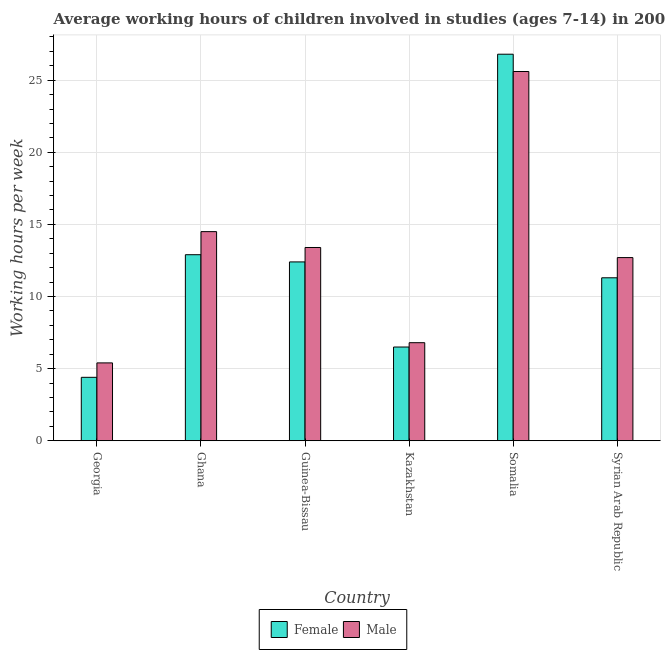How many groups of bars are there?
Ensure brevity in your answer.  6. Are the number of bars on each tick of the X-axis equal?
Your answer should be compact. Yes. How many bars are there on the 6th tick from the left?
Provide a short and direct response. 2. How many bars are there on the 2nd tick from the right?
Ensure brevity in your answer.  2. What is the label of the 6th group of bars from the left?
Your response must be concise. Syrian Arab Republic. What is the average working hour of female children in Syrian Arab Republic?
Offer a terse response. 11.3. Across all countries, what is the maximum average working hour of female children?
Make the answer very short. 26.8. Across all countries, what is the minimum average working hour of male children?
Provide a short and direct response. 5.4. In which country was the average working hour of male children maximum?
Ensure brevity in your answer.  Somalia. In which country was the average working hour of male children minimum?
Provide a short and direct response. Georgia. What is the total average working hour of male children in the graph?
Provide a succinct answer. 78.4. What is the difference between the average working hour of male children in Ghana and that in Guinea-Bissau?
Your response must be concise. 1.1. What is the difference between the average working hour of female children in Syrian Arab Republic and the average working hour of male children in Guinea-Bissau?
Make the answer very short. -2.1. What is the average average working hour of male children per country?
Your response must be concise. 13.07. What is the difference between the average working hour of male children and average working hour of female children in Ghana?
Your answer should be very brief. 1.6. What is the ratio of the average working hour of female children in Guinea-Bissau to that in Somalia?
Offer a very short reply. 0.46. Is the difference between the average working hour of female children in Somalia and Syrian Arab Republic greater than the difference between the average working hour of male children in Somalia and Syrian Arab Republic?
Ensure brevity in your answer.  Yes. What is the difference between the highest and the lowest average working hour of female children?
Your answer should be very brief. 22.4. In how many countries, is the average working hour of female children greater than the average average working hour of female children taken over all countries?
Provide a succinct answer. 3. What does the 1st bar from the right in Somalia represents?
Keep it short and to the point. Male. How many bars are there?
Give a very brief answer. 12. Are all the bars in the graph horizontal?
Offer a terse response. No. How many countries are there in the graph?
Make the answer very short. 6. Does the graph contain grids?
Your response must be concise. Yes. Where does the legend appear in the graph?
Make the answer very short. Bottom center. What is the title of the graph?
Provide a succinct answer. Average working hours of children involved in studies (ages 7-14) in 2006. Does "Transport services" appear as one of the legend labels in the graph?
Ensure brevity in your answer.  No. What is the label or title of the X-axis?
Your response must be concise. Country. What is the label or title of the Y-axis?
Your answer should be compact. Working hours per week. What is the Working hours per week in Female in Georgia?
Provide a short and direct response. 4.4. What is the Working hours per week in Male in Georgia?
Keep it short and to the point. 5.4. What is the Working hours per week in Male in Guinea-Bissau?
Make the answer very short. 13.4. What is the Working hours per week of Female in Somalia?
Provide a succinct answer. 26.8. What is the Working hours per week in Male in Somalia?
Offer a very short reply. 25.6. What is the Working hours per week in Female in Syrian Arab Republic?
Provide a succinct answer. 11.3. What is the Working hours per week in Male in Syrian Arab Republic?
Provide a succinct answer. 12.7. Across all countries, what is the maximum Working hours per week in Female?
Offer a very short reply. 26.8. Across all countries, what is the maximum Working hours per week in Male?
Ensure brevity in your answer.  25.6. Across all countries, what is the minimum Working hours per week of Female?
Provide a short and direct response. 4.4. Across all countries, what is the minimum Working hours per week in Male?
Your answer should be very brief. 5.4. What is the total Working hours per week of Female in the graph?
Your answer should be very brief. 74.3. What is the total Working hours per week in Male in the graph?
Provide a succinct answer. 78.4. What is the difference between the Working hours per week in Female in Georgia and that in Ghana?
Provide a short and direct response. -8.5. What is the difference between the Working hours per week of Male in Georgia and that in Ghana?
Keep it short and to the point. -9.1. What is the difference between the Working hours per week in Female in Georgia and that in Somalia?
Provide a short and direct response. -22.4. What is the difference between the Working hours per week of Male in Georgia and that in Somalia?
Your response must be concise. -20.2. What is the difference between the Working hours per week in Female in Georgia and that in Syrian Arab Republic?
Offer a very short reply. -6.9. What is the difference between the Working hours per week in Male in Georgia and that in Syrian Arab Republic?
Your answer should be very brief. -7.3. What is the difference between the Working hours per week of Female in Ghana and that in Somalia?
Your answer should be very brief. -13.9. What is the difference between the Working hours per week in Male in Ghana and that in Somalia?
Your response must be concise. -11.1. What is the difference between the Working hours per week of Female in Guinea-Bissau and that in Somalia?
Offer a very short reply. -14.4. What is the difference between the Working hours per week in Male in Guinea-Bissau and that in Syrian Arab Republic?
Make the answer very short. 0.7. What is the difference between the Working hours per week of Female in Kazakhstan and that in Somalia?
Keep it short and to the point. -20.3. What is the difference between the Working hours per week of Male in Kazakhstan and that in Somalia?
Your answer should be very brief. -18.8. What is the difference between the Working hours per week of Female in Somalia and that in Syrian Arab Republic?
Your response must be concise. 15.5. What is the difference between the Working hours per week in Female in Georgia and the Working hours per week in Male in Guinea-Bissau?
Your answer should be very brief. -9. What is the difference between the Working hours per week in Female in Georgia and the Working hours per week in Male in Somalia?
Provide a succinct answer. -21.2. What is the difference between the Working hours per week in Female in Ghana and the Working hours per week in Male in Kazakhstan?
Provide a short and direct response. 6.1. What is the difference between the Working hours per week in Female in Kazakhstan and the Working hours per week in Male in Somalia?
Your answer should be very brief. -19.1. What is the difference between the Working hours per week in Female in Kazakhstan and the Working hours per week in Male in Syrian Arab Republic?
Your answer should be compact. -6.2. What is the average Working hours per week in Female per country?
Your response must be concise. 12.38. What is the average Working hours per week of Male per country?
Provide a succinct answer. 13.07. What is the difference between the Working hours per week of Female and Working hours per week of Male in Georgia?
Make the answer very short. -1. What is the difference between the Working hours per week of Female and Working hours per week of Male in Ghana?
Provide a short and direct response. -1.6. What is the difference between the Working hours per week of Female and Working hours per week of Male in Guinea-Bissau?
Provide a short and direct response. -1. What is the difference between the Working hours per week of Female and Working hours per week of Male in Syrian Arab Republic?
Make the answer very short. -1.4. What is the ratio of the Working hours per week in Female in Georgia to that in Ghana?
Give a very brief answer. 0.34. What is the ratio of the Working hours per week of Male in Georgia to that in Ghana?
Provide a succinct answer. 0.37. What is the ratio of the Working hours per week in Female in Georgia to that in Guinea-Bissau?
Provide a succinct answer. 0.35. What is the ratio of the Working hours per week in Male in Georgia to that in Guinea-Bissau?
Provide a succinct answer. 0.4. What is the ratio of the Working hours per week in Female in Georgia to that in Kazakhstan?
Make the answer very short. 0.68. What is the ratio of the Working hours per week in Male in Georgia to that in Kazakhstan?
Ensure brevity in your answer.  0.79. What is the ratio of the Working hours per week in Female in Georgia to that in Somalia?
Keep it short and to the point. 0.16. What is the ratio of the Working hours per week of Male in Georgia to that in Somalia?
Give a very brief answer. 0.21. What is the ratio of the Working hours per week in Female in Georgia to that in Syrian Arab Republic?
Provide a succinct answer. 0.39. What is the ratio of the Working hours per week of Male in Georgia to that in Syrian Arab Republic?
Keep it short and to the point. 0.43. What is the ratio of the Working hours per week of Female in Ghana to that in Guinea-Bissau?
Keep it short and to the point. 1.04. What is the ratio of the Working hours per week in Male in Ghana to that in Guinea-Bissau?
Your response must be concise. 1.08. What is the ratio of the Working hours per week of Female in Ghana to that in Kazakhstan?
Offer a terse response. 1.98. What is the ratio of the Working hours per week in Male in Ghana to that in Kazakhstan?
Offer a very short reply. 2.13. What is the ratio of the Working hours per week in Female in Ghana to that in Somalia?
Provide a succinct answer. 0.48. What is the ratio of the Working hours per week of Male in Ghana to that in Somalia?
Ensure brevity in your answer.  0.57. What is the ratio of the Working hours per week of Female in Ghana to that in Syrian Arab Republic?
Offer a very short reply. 1.14. What is the ratio of the Working hours per week of Male in Ghana to that in Syrian Arab Republic?
Keep it short and to the point. 1.14. What is the ratio of the Working hours per week of Female in Guinea-Bissau to that in Kazakhstan?
Give a very brief answer. 1.91. What is the ratio of the Working hours per week of Male in Guinea-Bissau to that in Kazakhstan?
Your response must be concise. 1.97. What is the ratio of the Working hours per week in Female in Guinea-Bissau to that in Somalia?
Keep it short and to the point. 0.46. What is the ratio of the Working hours per week in Male in Guinea-Bissau to that in Somalia?
Offer a terse response. 0.52. What is the ratio of the Working hours per week of Female in Guinea-Bissau to that in Syrian Arab Republic?
Give a very brief answer. 1.1. What is the ratio of the Working hours per week of Male in Guinea-Bissau to that in Syrian Arab Republic?
Offer a very short reply. 1.06. What is the ratio of the Working hours per week in Female in Kazakhstan to that in Somalia?
Provide a succinct answer. 0.24. What is the ratio of the Working hours per week in Male in Kazakhstan to that in Somalia?
Make the answer very short. 0.27. What is the ratio of the Working hours per week of Female in Kazakhstan to that in Syrian Arab Republic?
Provide a short and direct response. 0.58. What is the ratio of the Working hours per week in Male in Kazakhstan to that in Syrian Arab Republic?
Provide a short and direct response. 0.54. What is the ratio of the Working hours per week of Female in Somalia to that in Syrian Arab Republic?
Offer a terse response. 2.37. What is the ratio of the Working hours per week in Male in Somalia to that in Syrian Arab Republic?
Your answer should be very brief. 2.02. What is the difference between the highest and the second highest Working hours per week in Female?
Provide a short and direct response. 13.9. What is the difference between the highest and the second highest Working hours per week in Male?
Give a very brief answer. 11.1. What is the difference between the highest and the lowest Working hours per week of Female?
Your answer should be compact. 22.4. What is the difference between the highest and the lowest Working hours per week in Male?
Your answer should be very brief. 20.2. 